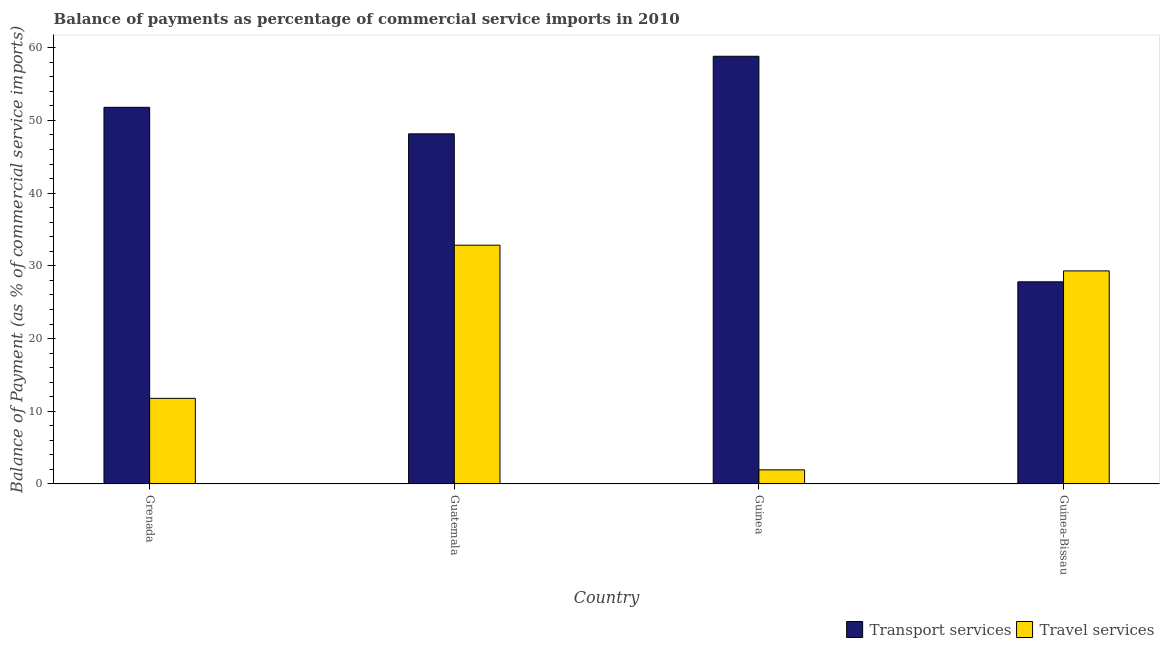How many different coloured bars are there?
Provide a succinct answer. 2. Are the number of bars per tick equal to the number of legend labels?
Provide a succinct answer. Yes. Are the number of bars on each tick of the X-axis equal?
Keep it short and to the point. Yes. How many bars are there on the 3rd tick from the left?
Offer a very short reply. 2. How many bars are there on the 3rd tick from the right?
Provide a short and direct response. 2. What is the label of the 3rd group of bars from the left?
Ensure brevity in your answer.  Guinea. What is the balance of payments of transport services in Grenada?
Ensure brevity in your answer.  51.8. Across all countries, what is the maximum balance of payments of transport services?
Offer a very short reply. 58.82. Across all countries, what is the minimum balance of payments of transport services?
Ensure brevity in your answer.  27.8. In which country was the balance of payments of transport services maximum?
Provide a succinct answer. Guinea. In which country was the balance of payments of transport services minimum?
Provide a succinct answer. Guinea-Bissau. What is the total balance of payments of transport services in the graph?
Your response must be concise. 186.57. What is the difference between the balance of payments of travel services in Guatemala and that in Guinea-Bissau?
Offer a terse response. 3.53. What is the difference between the balance of payments of transport services in Guinea-Bissau and the balance of payments of travel services in Guatemala?
Offer a terse response. -5.04. What is the average balance of payments of travel services per country?
Give a very brief answer. 18.97. What is the difference between the balance of payments of travel services and balance of payments of transport services in Guinea-Bissau?
Your response must be concise. 1.5. What is the ratio of the balance of payments of travel services in Grenada to that in Guinea-Bissau?
Your answer should be very brief. 0.4. Is the balance of payments of transport services in Guinea less than that in Guinea-Bissau?
Your answer should be very brief. No. Is the difference between the balance of payments of travel services in Grenada and Guatemala greater than the difference between the balance of payments of transport services in Grenada and Guatemala?
Your answer should be very brief. No. What is the difference between the highest and the second highest balance of payments of travel services?
Provide a succinct answer. 3.53. What is the difference between the highest and the lowest balance of payments of travel services?
Ensure brevity in your answer.  30.9. In how many countries, is the balance of payments of transport services greater than the average balance of payments of transport services taken over all countries?
Give a very brief answer. 3. What does the 2nd bar from the left in Grenada represents?
Offer a very short reply. Travel services. What does the 1st bar from the right in Guinea-Bissau represents?
Give a very brief answer. Travel services. How many bars are there?
Your response must be concise. 8. Are all the bars in the graph horizontal?
Offer a very short reply. No. What is the difference between two consecutive major ticks on the Y-axis?
Offer a terse response. 10. Are the values on the major ticks of Y-axis written in scientific E-notation?
Provide a short and direct response. No. Does the graph contain any zero values?
Ensure brevity in your answer.  No. Where does the legend appear in the graph?
Give a very brief answer. Bottom right. How many legend labels are there?
Make the answer very short. 2. How are the legend labels stacked?
Your answer should be very brief. Horizontal. What is the title of the graph?
Offer a very short reply. Balance of payments as percentage of commercial service imports in 2010. Does "Long-term debt" appear as one of the legend labels in the graph?
Your answer should be very brief. No. What is the label or title of the X-axis?
Provide a succinct answer. Country. What is the label or title of the Y-axis?
Offer a very short reply. Balance of Payment (as % of commercial service imports). What is the Balance of Payment (as % of commercial service imports) in Transport services in Grenada?
Keep it short and to the point. 51.8. What is the Balance of Payment (as % of commercial service imports) in Travel services in Grenada?
Keep it short and to the point. 11.78. What is the Balance of Payment (as % of commercial service imports) of Transport services in Guatemala?
Your answer should be compact. 48.15. What is the Balance of Payment (as % of commercial service imports) in Travel services in Guatemala?
Ensure brevity in your answer.  32.84. What is the Balance of Payment (as % of commercial service imports) of Transport services in Guinea?
Your response must be concise. 58.82. What is the Balance of Payment (as % of commercial service imports) in Travel services in Guinea?
Your response must be concise. 1.94. What is the Balance of Payment (as % of commercial service imports) in Transport services in Guinea-Bissau?
Make the answer very short. 27.8. What is the Balance of Payment (as % of commercial service imports) in Travel services in Guinea-Bissau?
Give a very brief answer. 29.3. Across all countries, what is the maximum Balance of Payment (as % of commercial service imports) in Transport services?
Your answer should be very brief. 58.82. Across all countries, what is the maximum Balance of Payment (as % of commercial service imports) of Travel services?
Your response must be concise. 32.84. Across all countries, what is the minimum Balance of Payment (as % of commercial service imports) in Transport services?
Offer a very short reply. 27.8. Across all countries, what is the minimum Balance of Payment (as % of commercial service imports) in Travel services?
Make the answer very short. 1.94. What is the total Balance of Payment (as % of commercial service imports) of Transport services in the graph?
Your answer should be compact. 186.57. What is the total Balance of Payment (as % of commercial service imports) in Travel services in the graph?
Offer a terse response. 75.86. What is the difference between the Balance of Payment (as % of commercial service imports) in Transport services in Grenada and that in Guatemala?
Ensure brevity in your answer.  3.65. What is the difference between the Balance of Payment (as % of commercial service imports) in Travel services in Grenada and that in Guatemala?
Provide a short and direct response. -21.06. What is the difference between the Balance of Payment (as % of commercial service imports) in Transport services in Grenada and that in Guinea?
Provide a succinct answer. -7.02. What is the difference between the Balance of Payment (as % of commercial service imports) of Travel services in Grenada and that in Guinea?
Your answer should be compact. 9.84. What is the difference between the Balance of Payment (as % of commercial service imports) of Transport services in Grenada and that in Guinea-Bissau?
Your answer should be very brief. 24. What is the difference between the Balance of Payment (as % of commercial service imports) of Travel services in Grenada and that in Guinea-Bissau?
Offer a terse response. -17.53. What is the difference between the Balance of Payment (as % of commercial service imports) in Transport services in Guatemala and that in Guinea?
Your answer should be compact. -10.67. What is the difference between the Balance of Payment (as % of commercial service imports) of Travel services in Guatemala and that in Guinea?
Your response must be concise. 30.9. What is the difference between the Balance of Payment (as % of commercial service imports) in Transport services in Guatemala and that in Guinea-Bissau?
Ensure brevity in your answer.  20.35. What is the difference between the Balance of Payment (as % of commercial service imports) in Travel services in Guatemala and that in Guinea-Bissau?
Provide a short and direct response. 3.53. What is the difference between the Balance of Payment (as % of commercial service imports) of Transport services in Guinea and that in Guinea-Bissau?
Your answer should be very brief. 31.02. What is the difference between the Balance of Payment (as % of commercial service imports) in Travel services in Guinea and that in Guinea-Bissau?
Provide a short and direct response. -27.36. What is the difference between the Balance of Payment (as % of commercial service imports) of Transport services in Grenada and the Balance of Payment (as % of commercial service imports) of Travel services in Guatemala?
Your answer should be compact. 18.96. What is the difference between the Balance of Payment (as % of commercial service imports) of Transport services in Grenada and the Balance of Payment (as % of commercial service imports) of Travel services in Guinea?
Make the answer very short. 49.86. What is the difference between the Balance of Payment (as % of commercial service imports) of Transport services in Grenada and the Balance of Payment (as % of commercial service imports) of Travel services in Guinea-Bissau?
Your answer should be compact. 22.5. What is the difference between the Balance of Payment (as % of commercial service imports) of Transport services in Guatemala and the Balance of Payment (as % of commercial service imports) of Travel services in Guinea?
Ensure brevity in your answer.  46.21. What is the difference between the Balance of Payment (as % of commercial service imports) of Transport services in Guatemala and the Balance of Payment (as % of commercial service imports) of Travel services in Guinea-Bissau?
Ensure brevity in your answer.  18.85. What is the difference between the Balance of Payment (as % of commercial service imports) of Transport services in Guinea and the Balance of Payment (as % of commercial service imports) of Travel services in Guinea-Bissau?
Give a very brief answer. 29.52. What is the average Balance of Payment (as % of commercial service imports) of Transport services per country?
Keep it short and to the point. 46.64. What is the average Balance of Payment (as % of commercial service imports) in Travel services per country?
Give a very brief answer. 18.97. What is the difference between the Balance of Payment (as % of commercial service imports) in Transport services and Balance of Payment (as % of commercial service imports) in Travel services in Grenada?
Give a very brief answer. 40.02. What is the difference between the Balance of Payment (as % of commercial service imports) in Transport services and Balance of Payment (as % of commercial service imports) in Travel services in Guatemala?
Provide a short and direct response. 15.31. What is the difference between the Balance of Payment (as % of commercial service imports) of Transport services and Balance of Payment (as % of commercial service imports) of Travel services in Guinea?
Give a very brief answer. 56.88. What is the difference between the Balance of Payment (as % of commercial service imports) in Transport services and Balance of Payment (as % of commercial service imports) in Travel services in Guinea-Bissau?
Offer a terse response. -1.5. What is the ratio of the Balance of Payment (as % of commercial service imports) in Transport services in Grenada to that in Guatemala?
Make the answer very short. 1.08. What is the ratio of the Balance of Payment (as % of commercial service imports) of Travel services in Grenada to that in Guatemala?
Offer a terse response. 0.36. What is the ratio of the Balance of Payment (as % of commercial service imports) of Transport services in Grenada to that in Guinea?
Your answer should be compact. 0.88. What is the ratio of the Balance of Payment (as % of commercial service imports) of Travel services in Grenada to that in Guinea?
Provide a succinct answer. 6.07. What is the ratio of the Balance of Payment (as % of commercial service imports) in Transport services in Grenada to that in Guinea-Bissau?
Keep it short and to the point. 1.86. What is the ratio of the Balance of Payment (as % of commercial service imports) of Travel services in Grenada to that in Guinea-Bissau?
Offer a very short reply. 0.4. What is the ratio of the Balance of Payment (as % of commercial service imports) in Transport services in Guatemala to that in Guinea?
Keep it short and to the point. 0.82. What is the ratio of the Balance of Payment (as % of commercial service imports) of Travel services in Guatemala to that in Guinea?
Provide a short and direct response. 16.91. What is the ratio of the Balance of Payment (as % of commercial service imports) in Transport services in Guatemala to that in Guinea-Bissau?
Offer a very short reply. 1.73. What is the ratio of the Balance of Payment (as % of commercial service imports) in Travel services in Guatemala to that in Guinea-Bissau?
Ensure brevity in your answer.  1.12. What is the ratio of the Balance of Payment (as % of commercial service imports) of Transport services in Guinea to that in Guinea-Bissau?
Provide a succinct answer. 2.12. What is the ratio of the Balance of Payment (as % of commercial service imports) of Travel services in Guinea to that in Guinea-Bissau?
Your response must be concise. 0.07. What is the difference between the highest and the second highest Balance of Payment (as % of commercial service imports) of Transport services?
Provide a short and direct response. 7.02. What is the difference between the highest and the second highest Balance of Payment (as % of commercial service imports) in Travel services?
Ensure brevity in your answer.  3.53. What is the difference between the highest and the lowest Balance of Payment (as % of commercial service imports) of Transport services?
Keep it short and to the point. 31.02. What is the difference between the highest and the lowest Balance of Payment (as % of commercial service imports) of Travel services?
Your response must be concise. 30.9. 